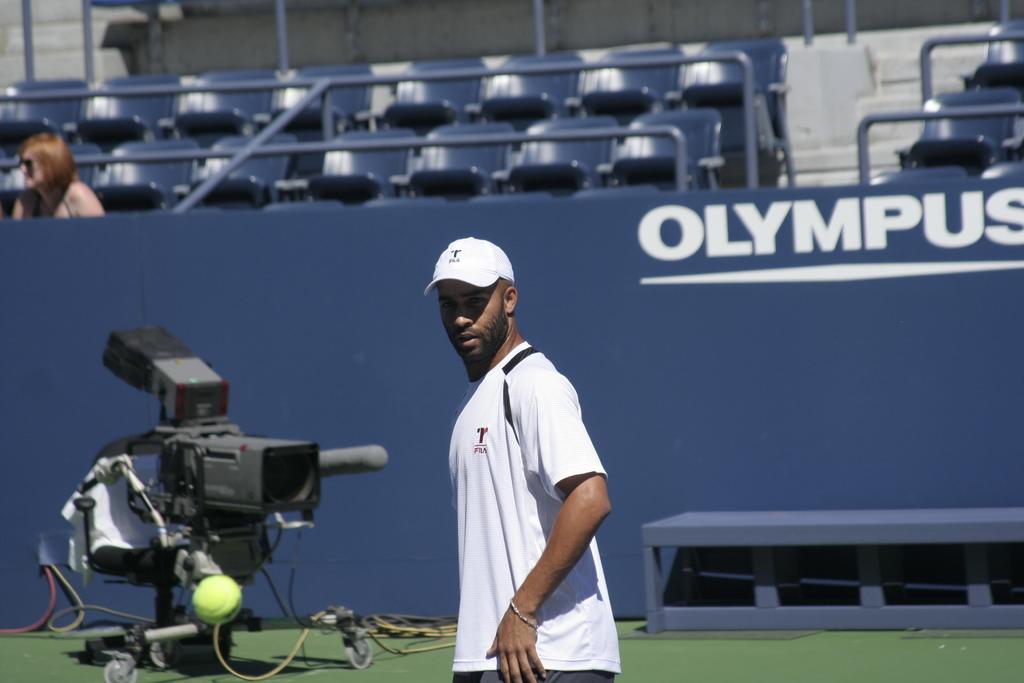Who is the sponsor of the stadium?
Provide a short and direct response. Olympus. 